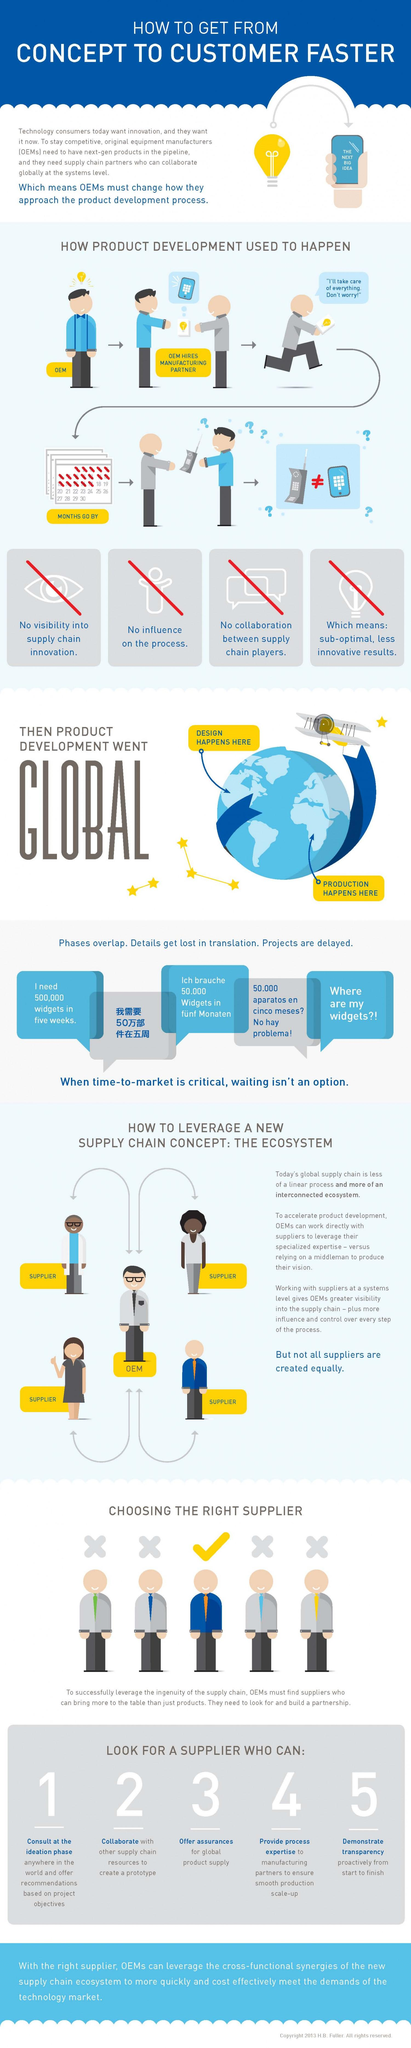Mention a couple of crucial points in this snapshot. We prioritize working with suppliers who possess process expertise and provide support to our manufacturing partners to ensure seamless production scale-up. The color of the bulb icon under the heading "blue, yellow or white?" is yellow. The second characteristic of a good supplier, according to the given list of 5, is their ability to collaborate with other supply chain resources to create a prototype. The third characteristic of a good supplier, according to the five given options, is the ability to provide assurances for global product supply. There are four cross mark symbols under the topic "choosing the right supplier. 